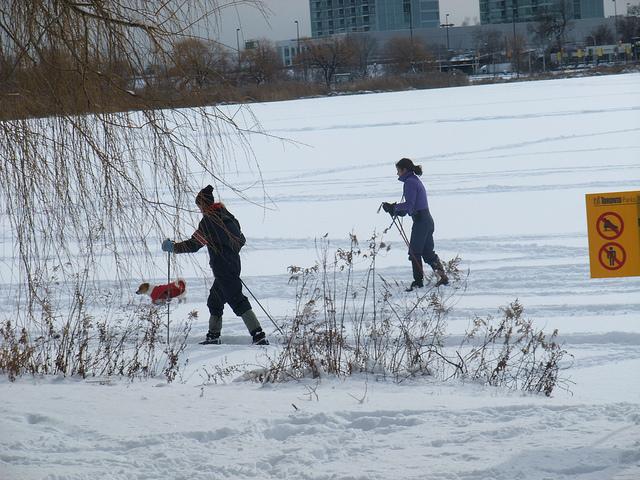Is it snowing in the picture?
Keep it brief. No. Can you see any animals in the photo?
Be succinct. Yes. Is the dog's mouth opened or closed?
Keep it brief. Closed. Is skating allowed?
Quick response, please. No. Which way is the sign facing?
Quick response, please. Forward. 